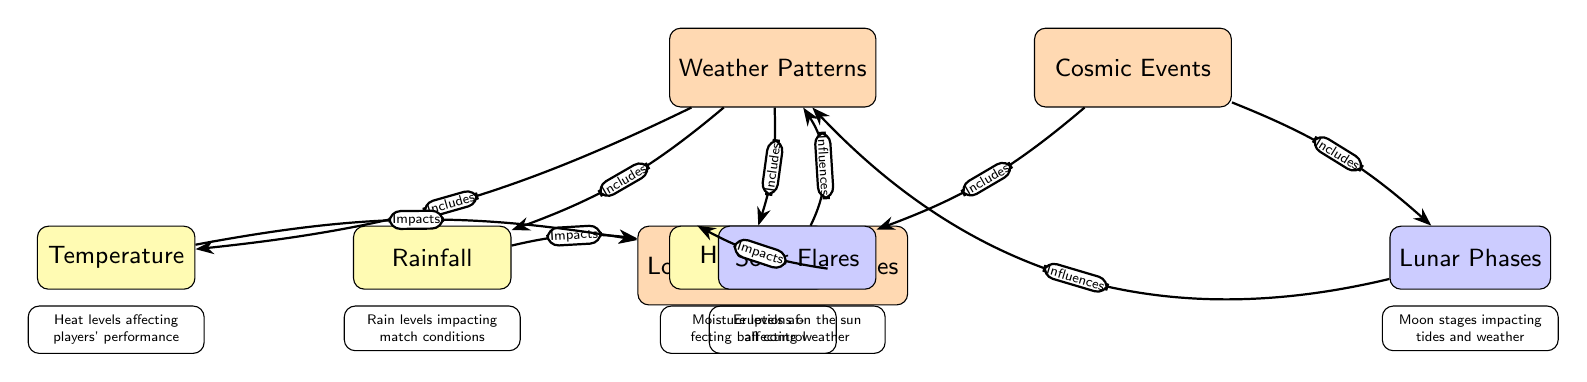What are the two main nodes in this diagram? The two main nodes are "Weather Patterns" and "Cosmic Events," which are prominently displayed at the top of the diagram.
Answer: Weather Patterns, Cosmic Events How many sub-nodes does the "Weather Patterns" node have? The "Weather Patterns" node has three sub-nodes: "Rainfall," "Temperature," and "Humidity," which are connected beneath it.
Answer: 3 What type of impact does "Rainfall" have on "Local Football Matches"? The diagram shows that "Rainfall" directly impacts "Local Football Matches," as indicated by an edge connecting them to demonstrate the relationship.
Answer: Impacts Which cosmic event influences "Weather Patterns"? The diagram indicates two cosmic events, "Solar Flares" and "Lunar Phases," both of which influence "Weather Patterns."
Answer: Solar Flares, Lunar Phases Describe how "Humidity" affects football matches. According to the diagram, "Humidity" impacts "Local Football Matches," implying that moisture levels affect how matches are played, especially ball control.
Answer: Impacts How does "Lunar Phases" relate to weather? "Lunar Phases" influences "Weather Patterns," suggesting that the phases of the moon can affect weather conditions, which is relevant for local football matches.
Answer: Influences What is one way "Temperature" affects players? The edge connecting "Temperature" to "Local Football Matches" shows that it impacts players’ performance, indicating how heat levels can affect their play.
Answer: Impacts What kind of weather factors does the "Weather Patterns" node include? The "Weather Patterns" node includes "Rainfall," "Temperature," and "Humidity," which are essential weather components that affect local football.
Answer: Rainfall, Temperature, Humidity What relationship do "Solar Flares" have with other elements in the diagram? "Solar Flares" influences "Weather Patterns," indicating that solar activity can indirectly affect the weather, and thus impact local football matches.
Answer: Influences 